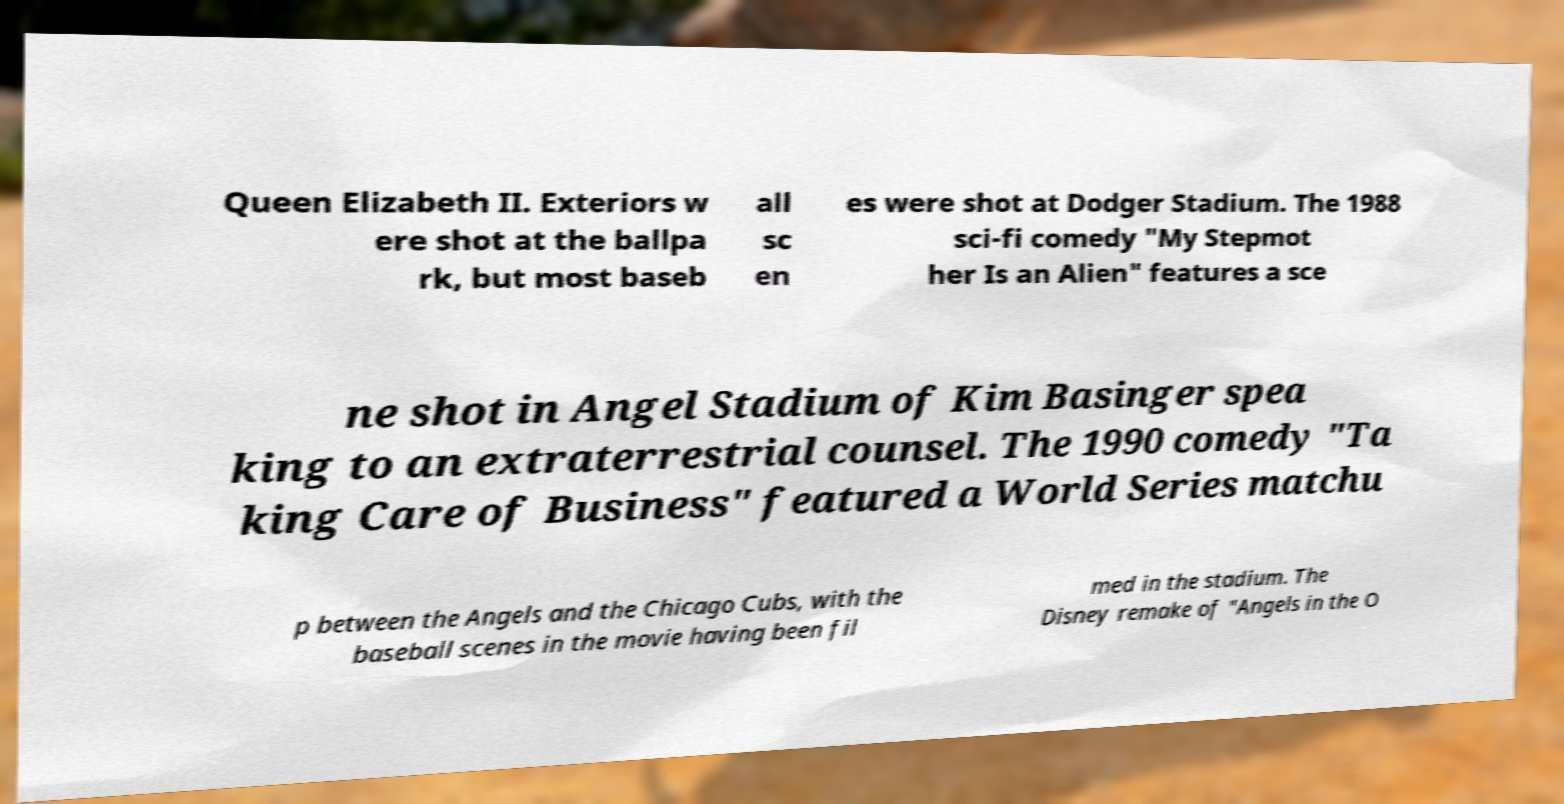Please identify and transcribe the text found in this image. Queen Elizabeth II. Exteriors w ere shot at the ballpa rk, but most baseb all sc en es were shot at Dodger Stadium. The 1988 sci-fi comedy "My Stepmot her Is an Alien" features a sce ne shot in Angel Stadium of Kim Basinger spea king to an extraterrestrial counsel. The 1990 comedy "Ta king Care of Business" featured a World Series matchu p between the Angels and the Chicago Cubs, with the baseball scenes in the movie having been fil med in the stadium. The Disney remake of "Angels in the O 